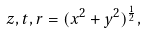<formula> <loc_0><loc_0><loc_500><loc_500>z , t , r = ( x ^ { 2 } + y ^ { 2 } ) ^ { \frac { 1 } { 2 } } ,</formula> 